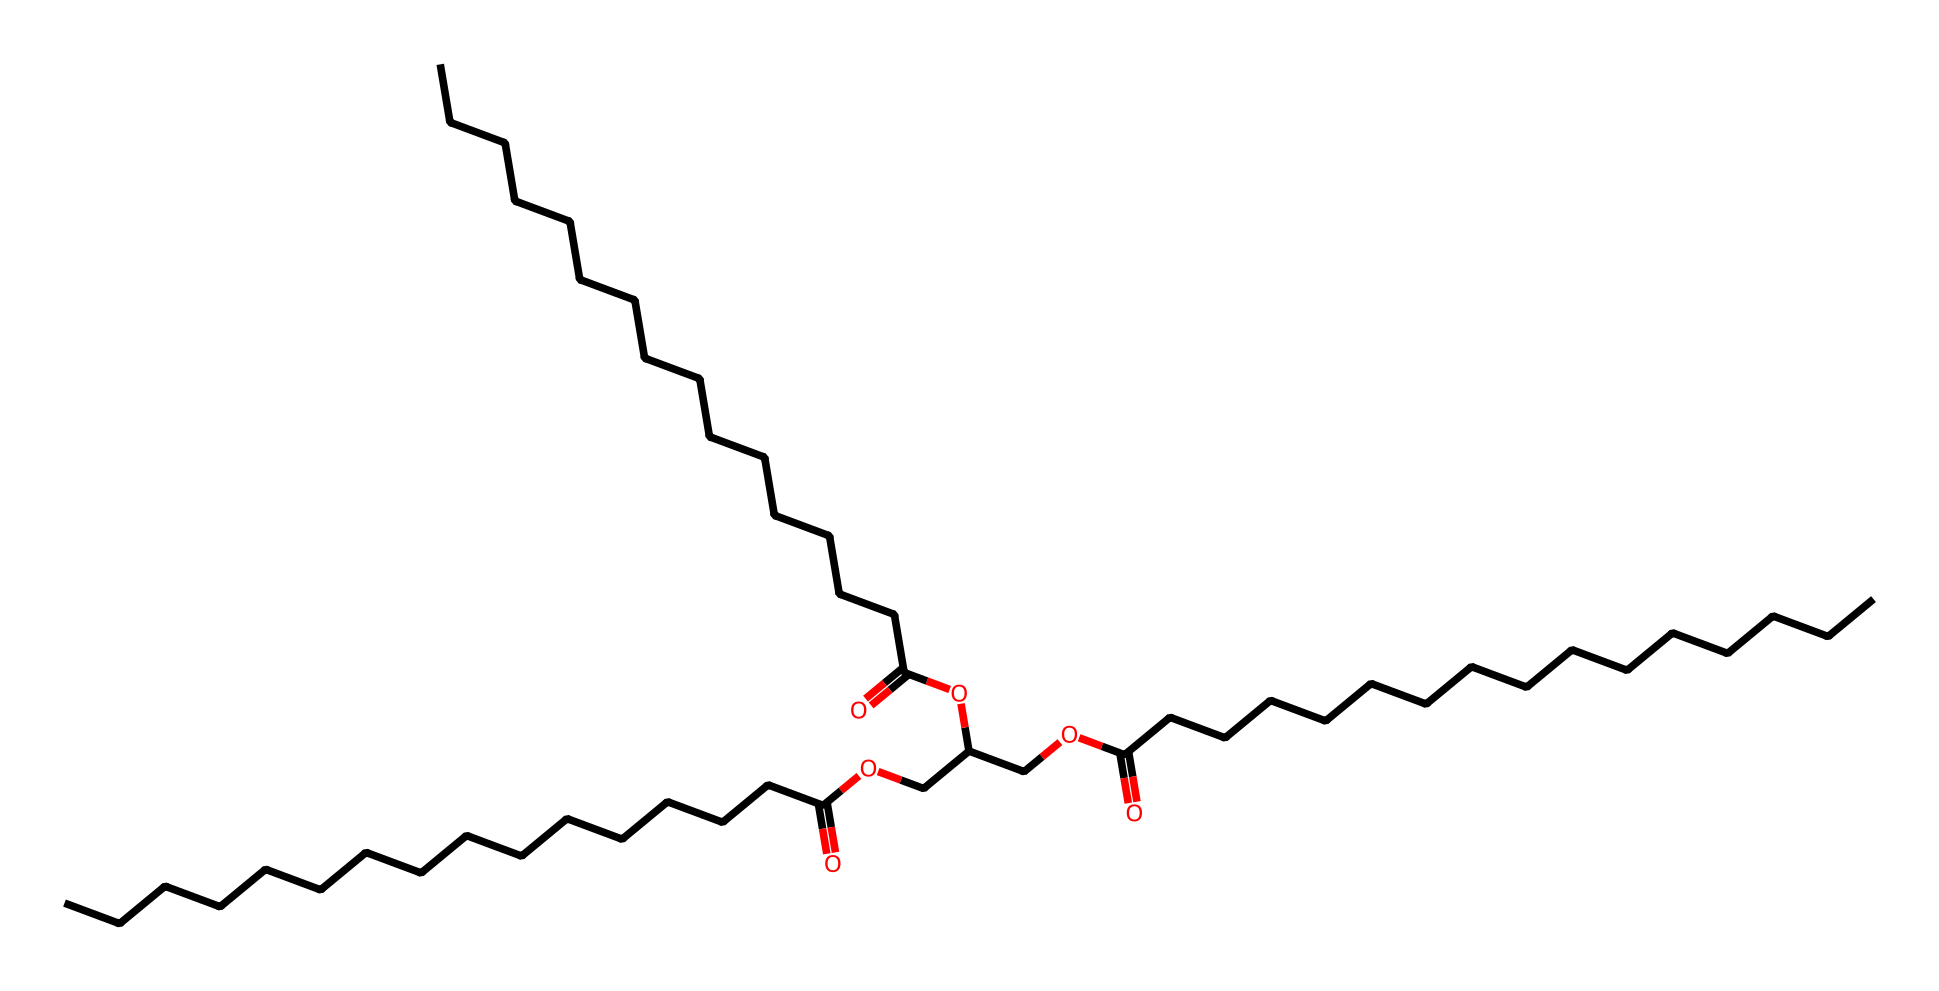what is the basic structure shown in this SMILES representation? The SMILES representation depicts a triglyceride, which consists of a glycerol backbone esterified with three fatty acid chains. The long hydrocarbon chains and ester groups indicate a lipid structure specifically for energy storage.
Answer: triglyceride how many carbon atoms are present in the molecule? By interpreting the SMILES, we can count the carbon atoms in all the fatty acid chains and the glycerol backbone. There are 36 carbon atoms indicated in the entire structure.
Answer: 36 what type of functional group is prominently featured in this structure? The presence of ester functional groups is evident from the "OC(=O)" sequences in the SMILES which connect the fatty acid chains to the glycerol backbone, making this lipid primarily composed of ester groups.
Answer: ester how does the structure contribute to energy storage? The long hydrocarbon chains in triglycerides contain many C–H bonds, which are high-energy bonds. These bonds can be broken down through metabolism, producing energy, thus making triglycerides efficient energy storage molecules.
Answer: high-energy bonds what differentiates triglycerides from phospholipids? Triglycerides consist of three fatty acids attached to a glycerol molecule, while phospholipids have two fatty acids and a phosphate group. The presence of a phosphate differentiates phospholipids from triglycerides.
Answer: phosphate group what is the primary biological function of triglycerides? Triglycerides serve primarily as a form of energy storage in adipose tissues, providing a significant energy reserve for the organism when needed.
Answer: energy storage how many ester bonds are formed in this structure? There are three fatty acid chains connected to the glycerol backbone, each forming one ester bond, thus we can conclude that there are three ester bonds in total.
Answer: three 